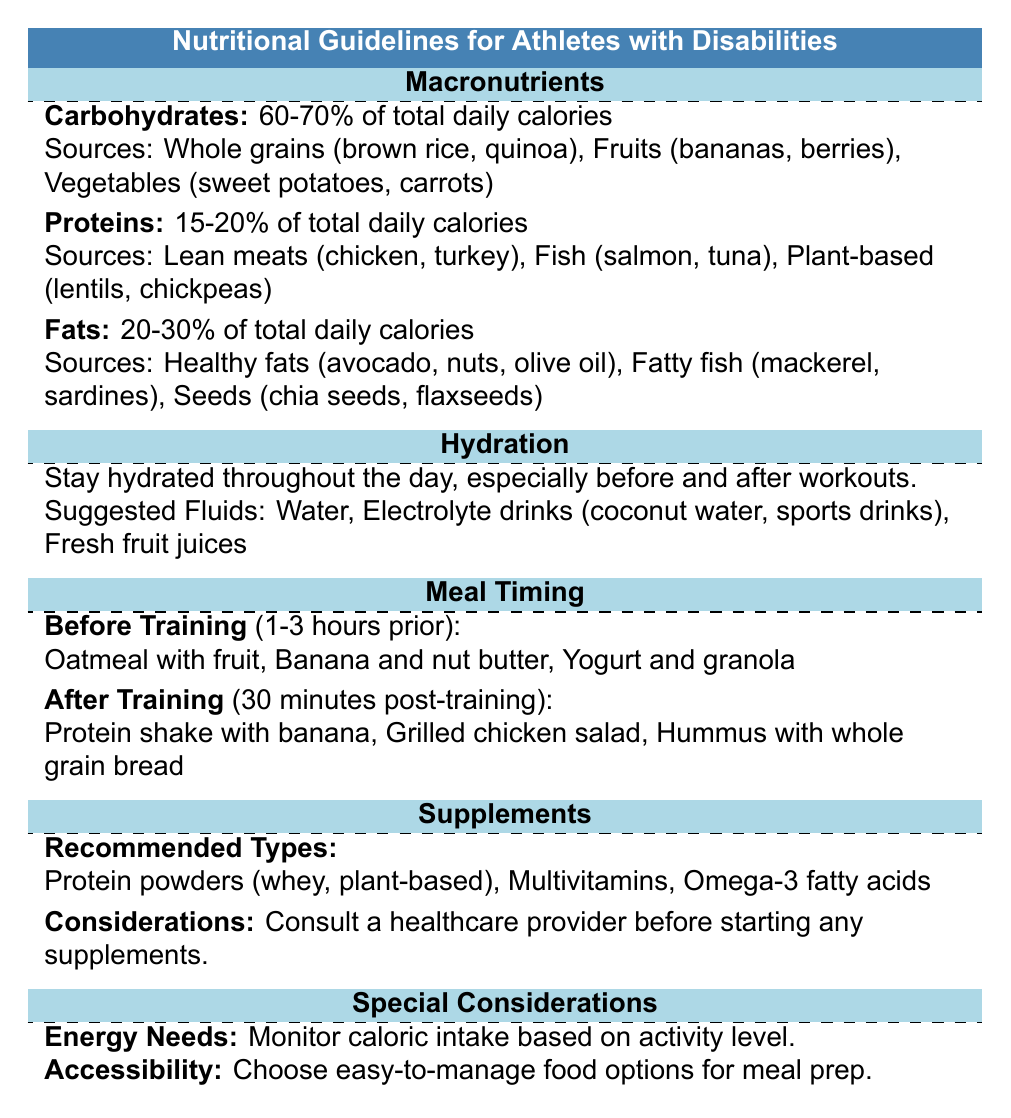What is the recommended percentage of carbohydrates in the diet? The table states that carbohydrates should make up 60-70% of total daily calories.
Answer: 60-70% What are some sources of protein listed in the guidelines? The table lists several sources of protein, including lean meats (chicken, turkey), fish (salmon, tuna), and plant-based sources (lentils, chickpeas).
Answer: Lean meats, fish, plant-based sources How often should hydration be monitored according to the guidelines? The guidelines recommend staying hydrated throughout the day, focusing especially on hydration before and after workouts, indicating that hydration should be monitored continuously.
Answer: Throughout the day Is a protein shake suggested after training? Yes, the guidelines suggest having a protein shake with banana 30 minutes post-training as part of the after-training meal plan.
Answer: Yes What is the total recommended caloric intake range for fats? The table states that fats should account for 20-30% of total daily calories. Therefore, to find the range, we look at the total caloric intake—20% to 30% shares of the same reference range ensure that fats are included alongside the total daily caloric recommendations.
Answer: 20-30% If an athlete's hydration includes coconut water and fresh fruit juices, is that following the guidelines? Yes, the suggested fluids list includes coconut water and fresh fruit juices as appropriate hydration options. Therefore, including these meets the guidelines provided in the table.
Answer: Yes What should an athlete consume before training according to the guidelines? The table recommends consuming oatmeal with fruit, banana and nut butter, or yogurt and granola 1-3 hours prior to training. This indicates that these foods are suggested for optimal performance.
Answer: Oatmeal with fruit, banana and nut butter, yogurt and granola If one were to take protein powders, what types are recommended? The table mentions that recommended types of protein powders include whey and plant-based options along with multivitamins and omega-3 fatty acids, indicating that focusing on these specific powders is essential.
Answer: Whey, plant-based What is the caloric monitoring approach suggested for individuals with disabilities? The guidelines suggest monitoring caloric intake based on activity level, which means adjusting caloric consumption based on how active the athlete is, accounting for fluctuations in energy expenditure.
Answer: Monitor caloric intake based on activity level 